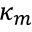Convert formula to latex. <formula><loc_0><loc_0><loc_500><loc_500>\kappa _ { m }</formula> 